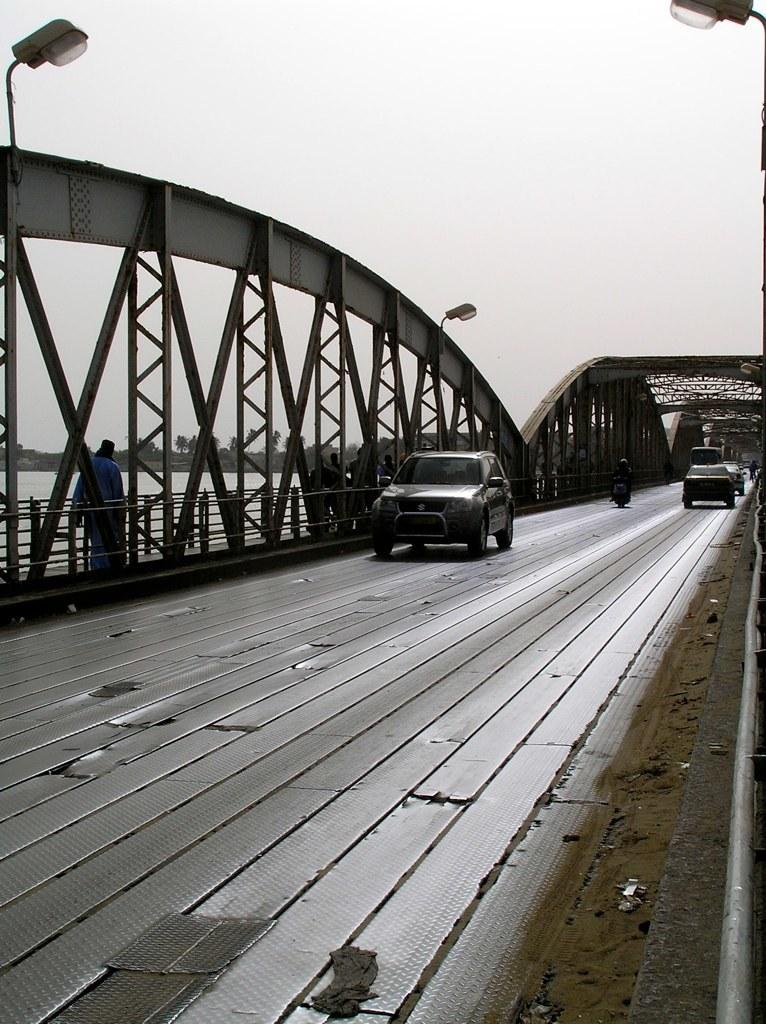What structure is present in the image? There is a bridge in the image. What is happening on the bridge or near it? There are vehicles on the road in the image. What can be seen at the top of the image? There are lights visible at the top of the image. What type of hair can be seen on the scarecrow in the image? There is no scarecrow present in the image, so there is no hair to observe. 